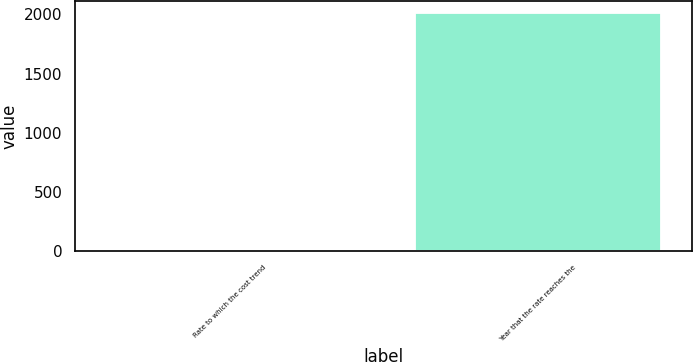Convert chart to OTSL. <chart><loc_0><loc_0><loc_500><loc_500><bar_chart><fcel>Rate to which the cost trend<fcel>Year that the rate reaches the<nl><fcel>5<fcel>2009<nl></chart> 